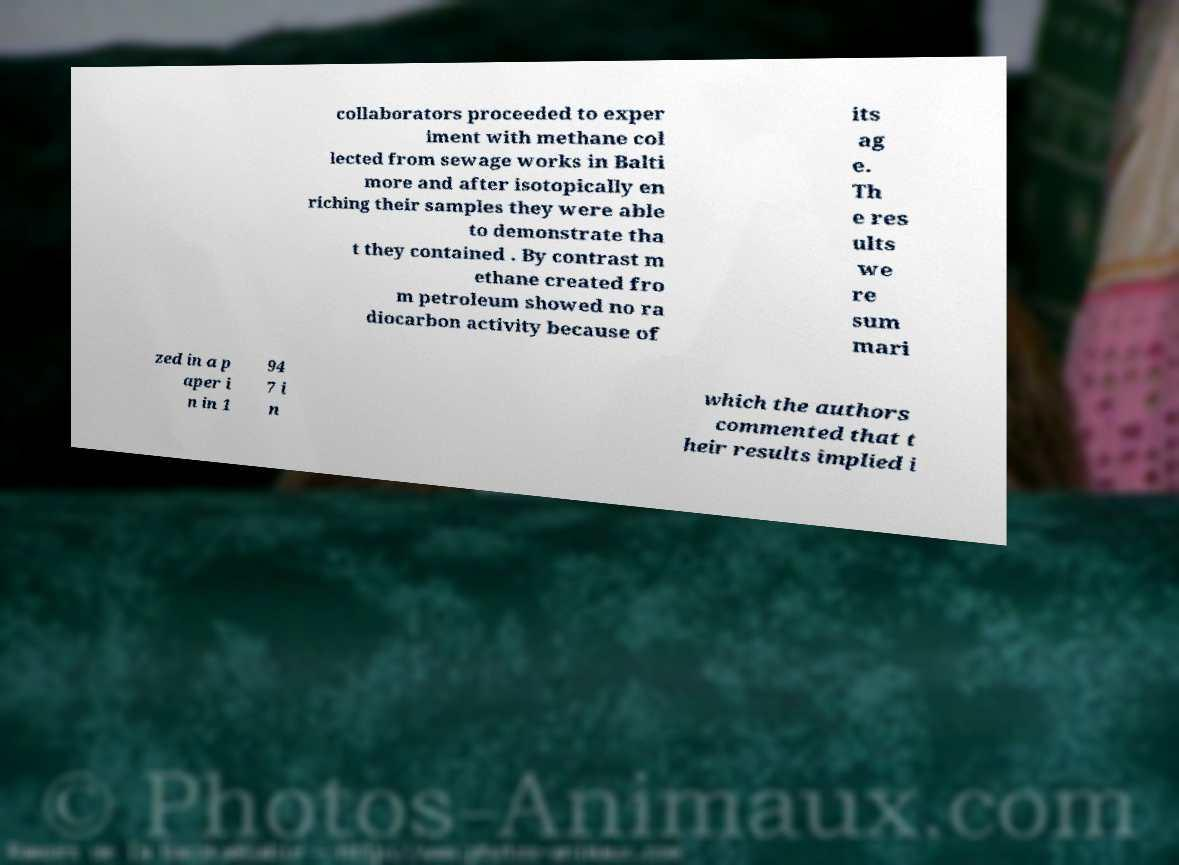Could you extract and type out the text from this image? collaborators proceeded to exper iment with methane col lected from sewage works in Balti more and after isotopically en riching their samples they were able to demonstrate tha t they contained . By contrast m ethane created fro m petroleum showed no ra diocarbon activity because of its ag e. Th e res ults we re sum mari zed in a p aper i n in 1 94 7 i n which the authors commented that t heir results implied i 